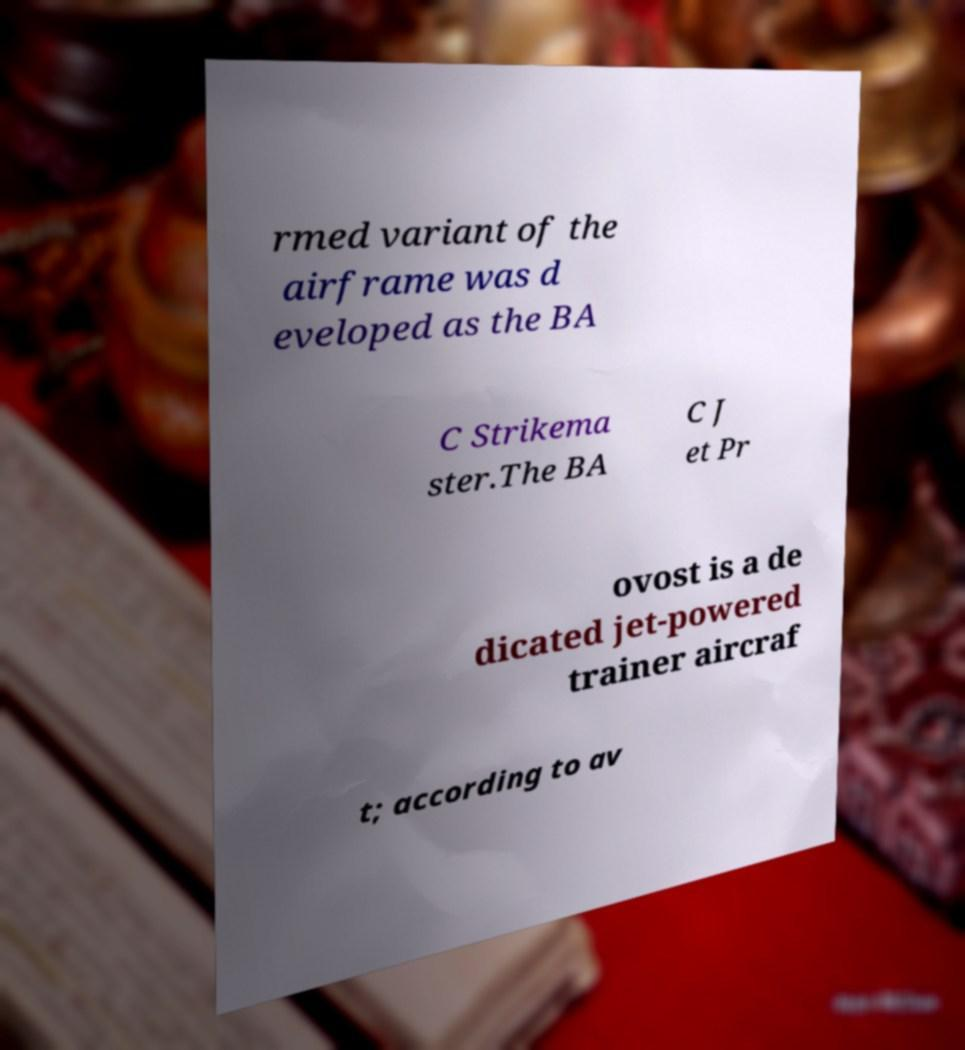Can you accurately transcribe the text from the provided image for me? rmed variant of the airframe was d eveloped as the BA C Strikema ster.The BA C J et Pr ovost is a de dicated jet-powered trainer aircraf t; according to av 